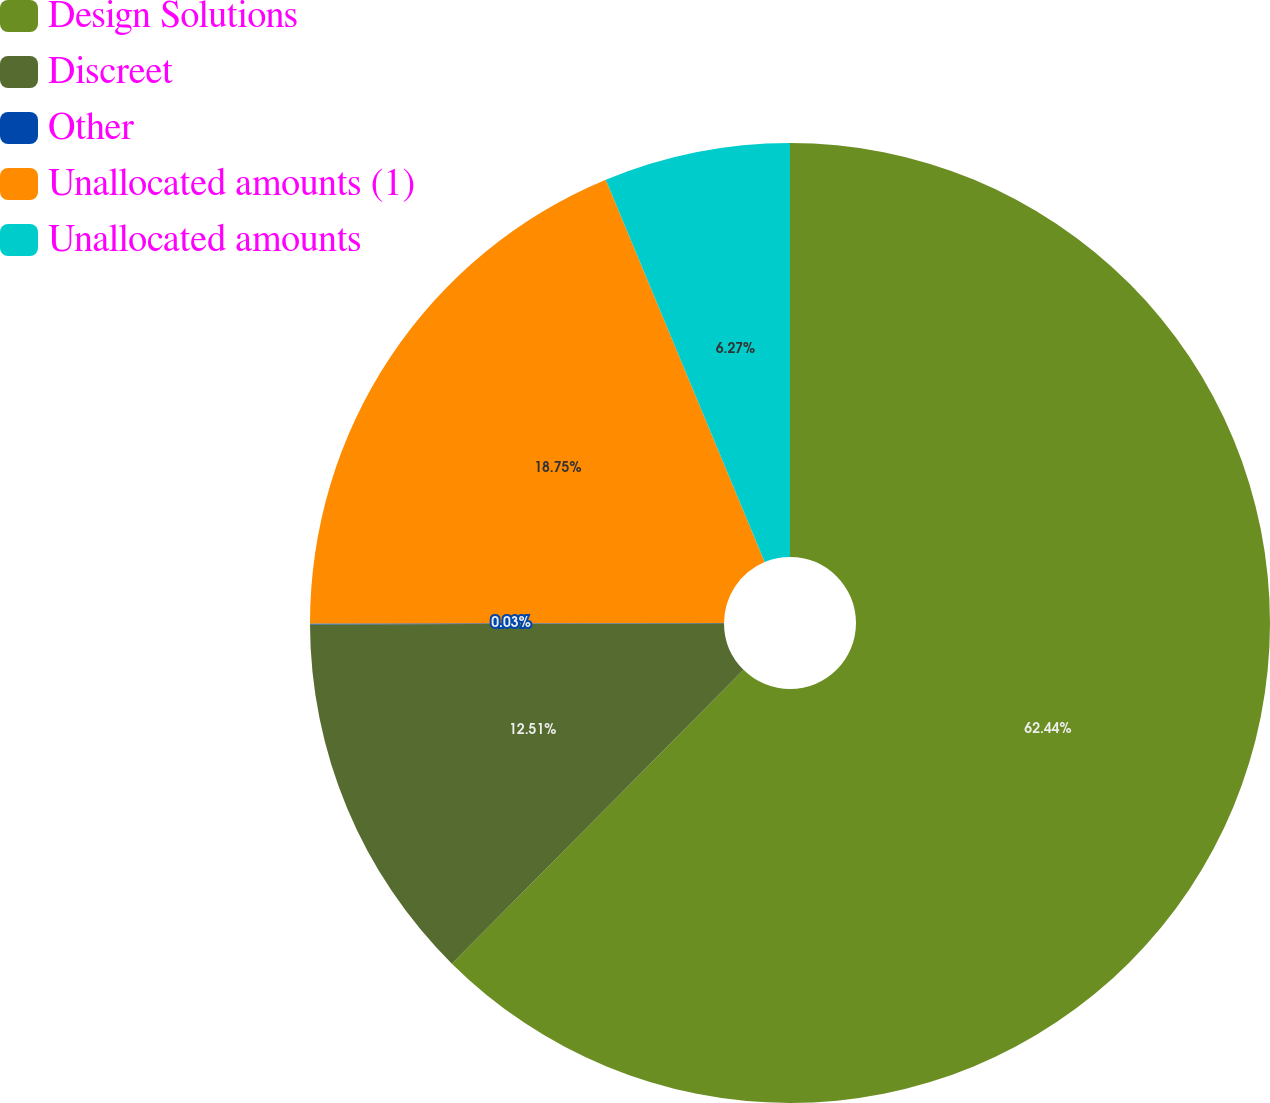Convert chart to OTSL. <chart><loc_0><loc_0><loc_500><loc_500><pie_chart><fcel>Design Solutions<fcel>Discreet<fcel>Other<fcel>Unallocated amounts (1)<fcel>Unallocated amounts<nl><fcel>62.44%<fcel>12.51%<fcel>0.03%<fcel>18.75%<fcel>6.27%<nl></chart> 